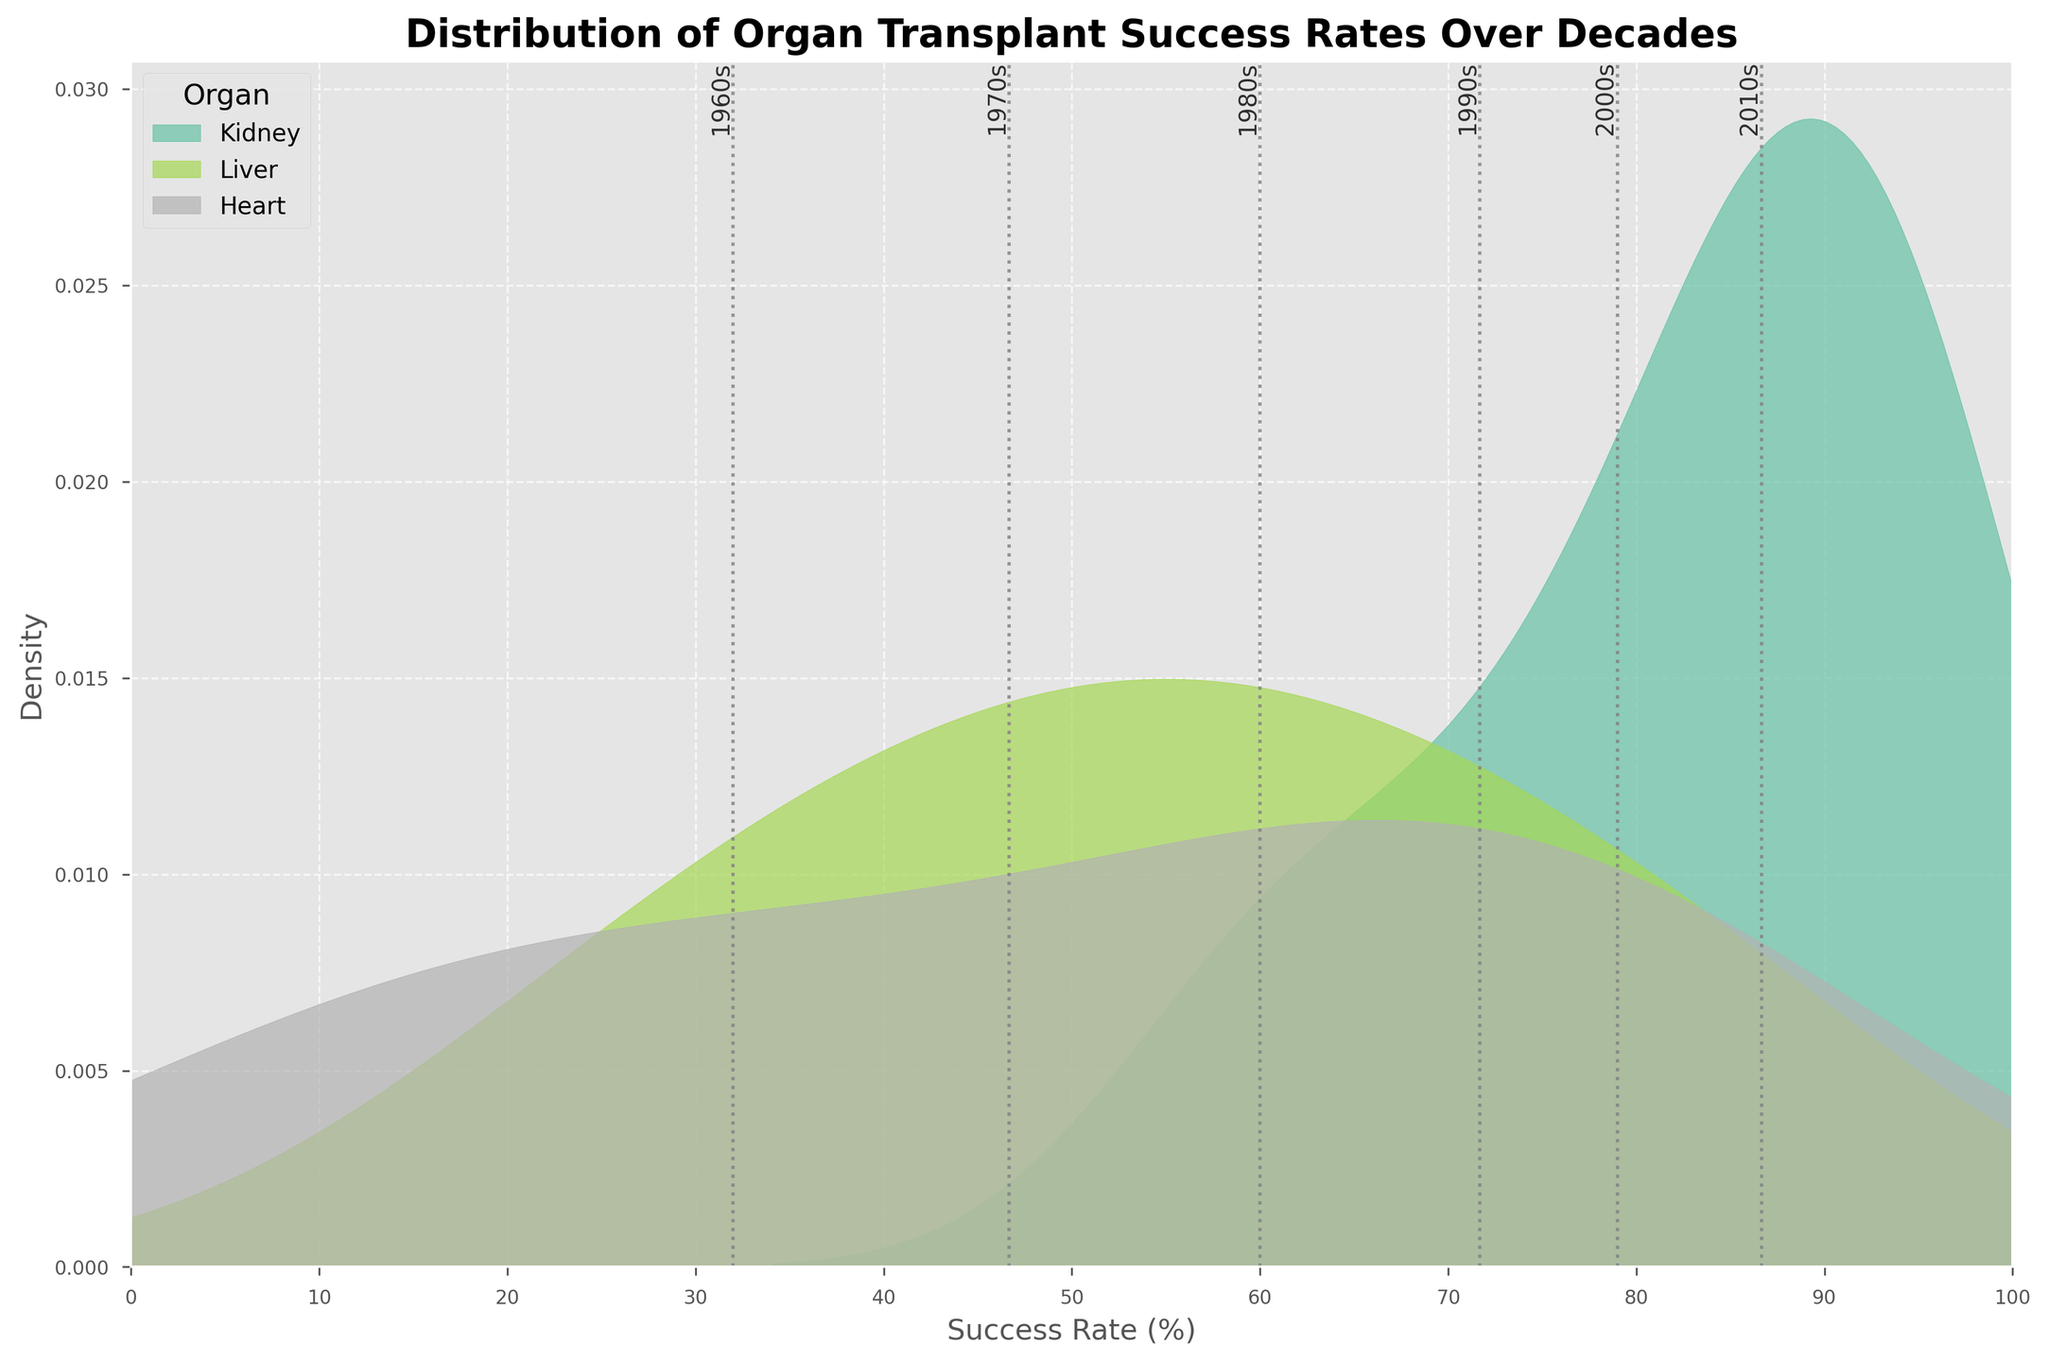What is the title of the plot? The title is displayed at the top of the plot in bold letters. It reads "Distribution of Organ Transplant Success Rates Over Decades."
Answer: Distribution of Organ Transplant Success Rates Over Decades What are the axes labels of the plot? The horizontal axis is labeled "Success Rate (%)" and the vertical axis is labeled "Density."
Answer: Success Rate (%), Density Which organ has the highest success rate density in the 2010s? The plot shows density curves for each organ. The liver's density curve peaks at the highest success rate level in the 2010s.
Answer: Liver Which decade has the lowest mean success rate for liver transplants? Looking at the gray vertical lines corresponding to different decades on the plot, the 1960s mean is positioned at the lowest success rate on the density curve for the liver.
Answer: 1960s How do heart transplant success rates change from the 1960s to the 2010s? Heart transplant success rates increase steadily over the decades. The specific success rates are visible on the density plots from 10% in the 1960s to 80% in the 2010s.
Answer: Increase Which organ shows the least variability in success rates? The variability can be observed by the spread of the density curves. Kidney transplant success rates have the least spread, showing the least variability.
Answer: Kidney What is the range of success rates for kidney transplants in the 2010s? For the 2010s, the kidney density curve peaks near 95%, with minimal spread. Thus, the success rate range is around 95%.
Answer: Around 95% How does the success rate of liver transplants in the 2000s compare to the 1980s? The density peak for the liver in the 2000s is higher than in the 1980s, indicating an improvement in success rates.
Answer: Improvement Which decade shows the most significant improvement in heart transplant success rates? Observing the vertical lines and density curve shifts, the transition from the 1980s to the 1990s shows the most significant improvement in heart transplant success rates.
Answer: 1990s What is the mean success rate for kidney transplants in the 1970s? The vertical gray line for the 1970s decade intersects the kidney density curve approximately at the 75% success rate level.
Answer: 75% 